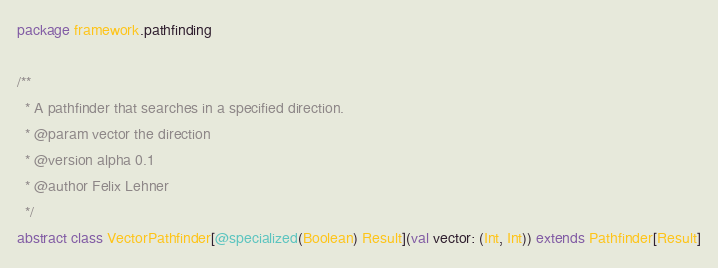<code> <loc_0><loc_0><loc_500><loc_500><_Scala_>package framework.pathfinding

/**
  * A pathfinder that searches in a specified direction.
  * @param vector the direction
  * @version alpha 0.1
  * @author Felix Lehner
  */
abstract class VectorPathfinder[@specialized(Boolean) Result](val vector: (Int, Int)) extends Pathfinder[Result]
</code> 